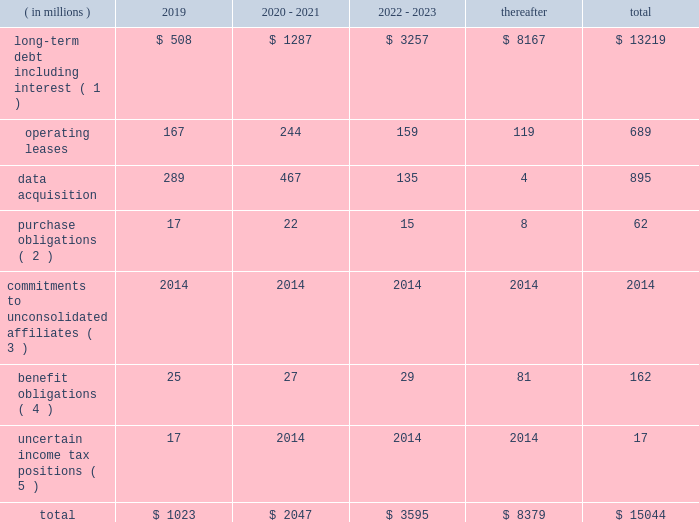Contingencies we are exposed to certain known contingencies that are material to our investors .
The facts and circumstances surrounding these contingencies and a discussion of their effect on us are in note 12 to our audited consolidated financial statements included elsewhere in this annual report on form 10-k .
These contingencies may have a material effect on our liquidity , capital resources or results of operations .
In addition , even where our reserves are adequate , the incurrence of any of these liabilities may have a material effect on our liquidity and the amount of cash available to us for other purposes .
We believe that we have made appropriate arrangements in respect of the future effect on us of these known contingencies .
We also believe that the amount of cash available to us from our operations , together with cash from financing , will be sufficient for us to pay any known contingencies as they become due without materially affecting our ability to conduct our operations and invest in the growth of our business .
Off-balance sheet arrangements we do not have any off-balance sheet arrangements except for operating leases entered into in the normal course of business .
Contractual obligations and commitments below is a summary of our future payment commitments by year under contractual obligations as of december 31 , 2018: .
( 1 ) interest payments on our debt are based on the interest rates in effect on december 31 , 2018 .
( 2 ) purchase obligations are defined as agreements to purchase goods or services that are enforceable and legally binding and that specify all significant terms , including fixed or minimum quantities to be purchased , fixed , minimum or variable pricing provisions and the approximate timing of the transactions .
( 3 ) we are currently committed to invest $ 120 million in private equity funds .
As of december 31 , 2018 , we have funded approximately $ 78 million of these commitments and we have approximately $ 42 million remaining to be funded which has not been included in the above table as we are unable to predict when these commitments will be paid .
( 4 ) amounts represent expected future benefit payments for our pension and postretirement benefit plans , as well as expected contributions for 2019 for our funded pension benefit plans .
We made cash contributions totaling approximately $ 31 million to our defined benefit plans in 2018 , and we estimate that we will make contributions totaling approximately $ 25 million to our defined benefit plans in 2019 .
Due to the potential impact of future plan investment performance , changes in interest rates , changes in other economic and demographic assumptions and changes in legislation in foreign jurisdictions , we are not able to reasonably estimate the timing and amount of contributions that may be required to fund our defined benefit plans for periods beyond 2019 .
( 5 ) as of december 31 , 2018 , our liability related to uncertain income tax positions was approximately $ 106 million , $ 89 million of which has not been included in the above table as we are unable to predict when these liabilities will be paid due to the uncertainties in the timing of the settlement of the income tax positions. .
What is the percentage change in benefits obligations from 2018 to 2019? 
Computations: ((25 - 31) / 31)
Answer: -0.19355. 